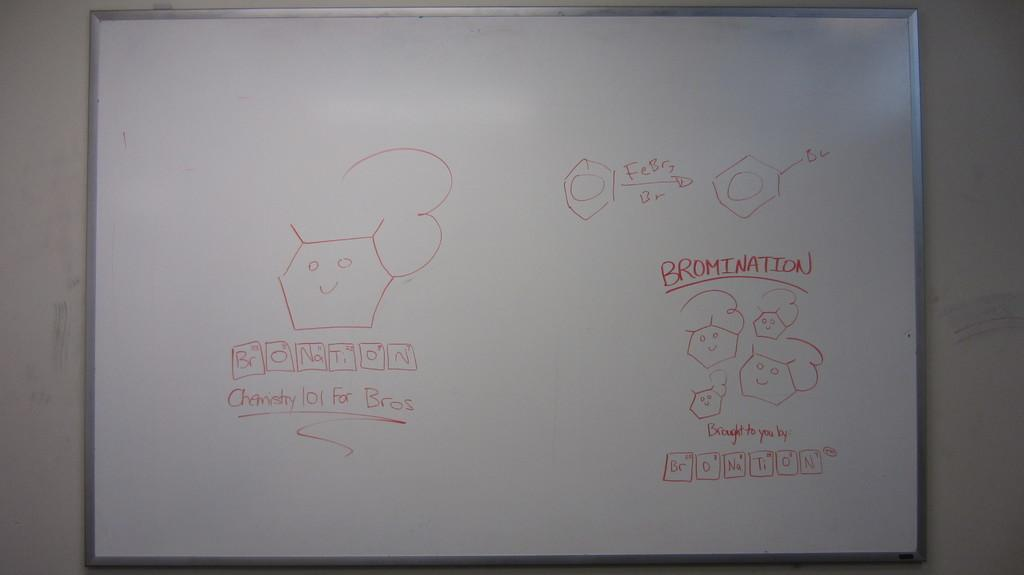<image>
Render a clear and concise summary of the photo. The word bromination is written on a white board. 